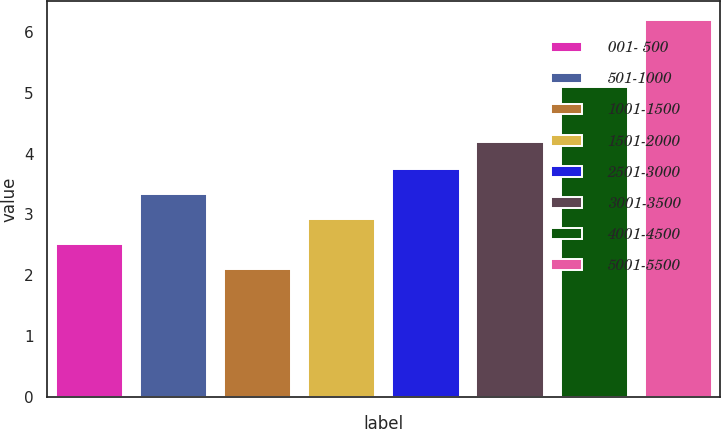Convert chart. <chart><loc_0><loc_0><loc_500><loc_500><bar_chart><fcel>001- 500<fcel>501-1000<fcel>1001-1500<fcel>1501-2000<fcel>2501-3000<fcel>3001-3500<fcel>4001-4500<fcel>5001-5500<nl><fcel>2.51<fcel>3.33<fcel>2.1<fcel>2.92<fcel>3.74<fcel>4.2<fcel>5.1<fcel>6.2<nl></chart> 